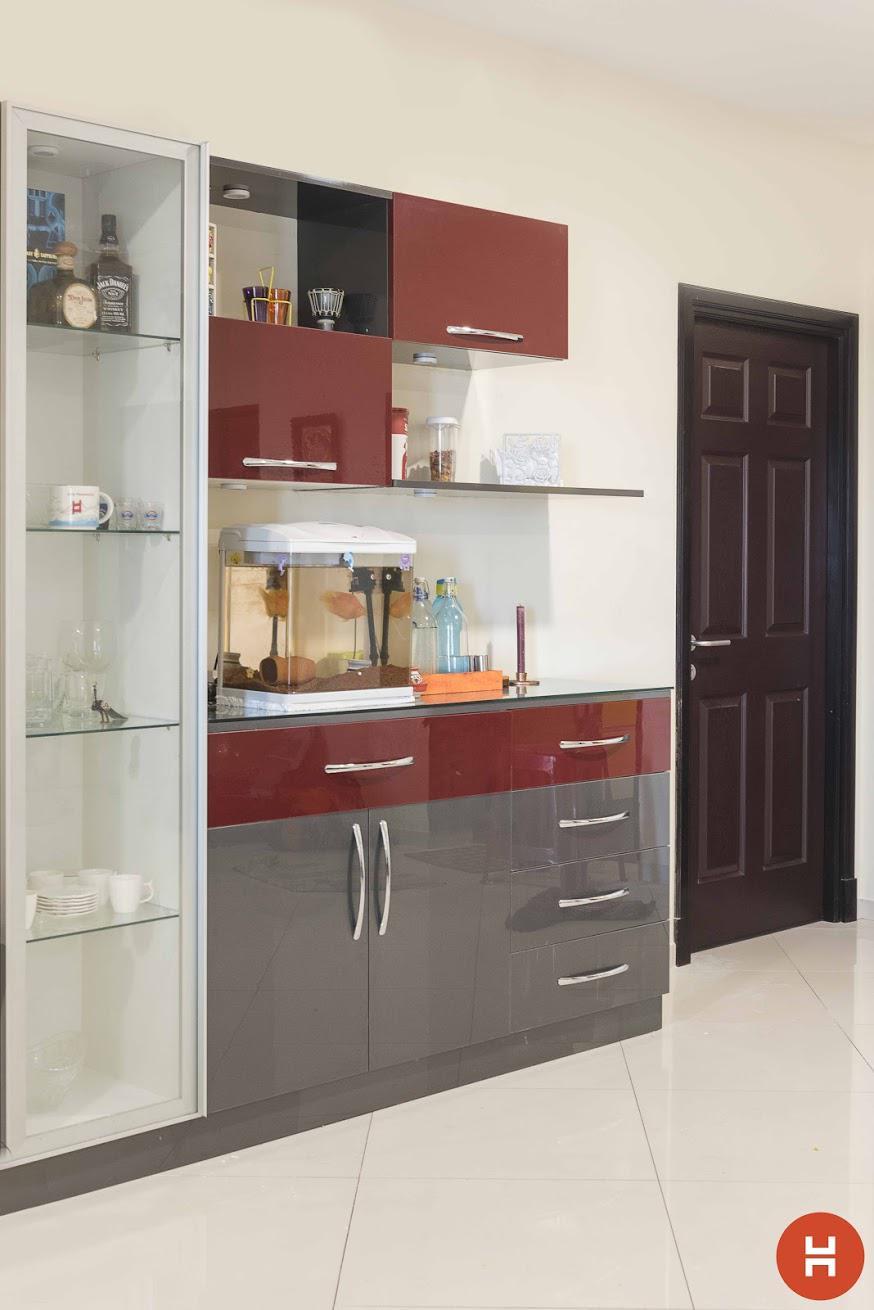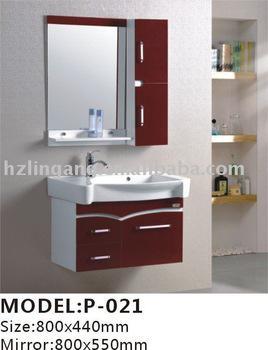The first image is the image on the left, the second image is the image on the right. Considering the images on both sides, is "Atleast one picture has black cabinets." valid? Answer yes or no. No. The first image is the image on the left, the second image is the image on the right. Examine the images to the left and right. Is the description "The right image shows glass-fronted black cabinets mounted on the wall above a counter with black cabinets that sits on the floor." accurate? Answer yes or no. No. 